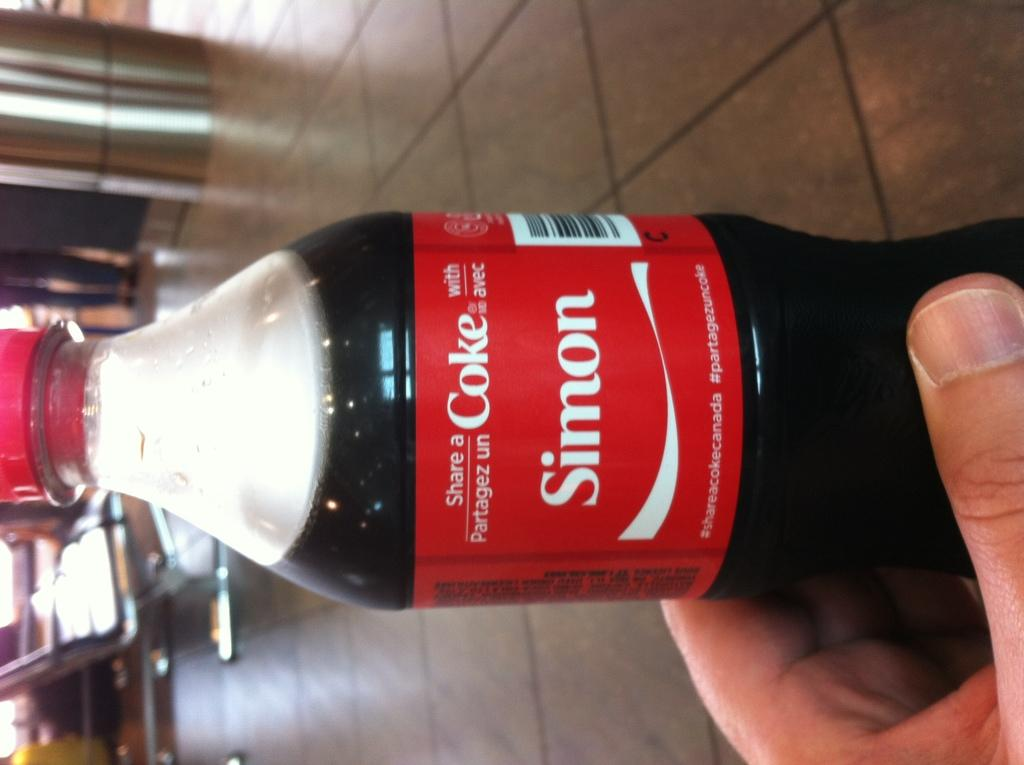What type of drink container is in the image? There is a cool drink bottle in the image. Whose hand is visible in the image? A person's hand is visible in the image. What can be seen in the background of the image? There are chairs and a pillar in the background of the image. What part of the person's body is visible besides their hand? The legs of a person are visible in the image. What type of hose is being used to water the plants in the image? There is no hose or plants present in the image. How many horses are visible in the image? There are no horses present in the image. 